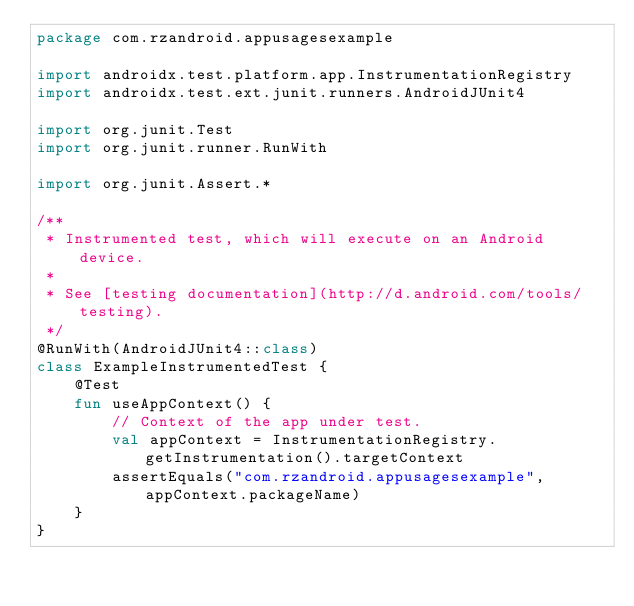<code> <loc_0><loc_0><loc_500><loc_500><_Kotlin_>package com.rzandroid.appusagesexample

import androidx.test.platform.app.InstrumentationRegistry
import androidx.test.ext.junit.runners.AndroidJUnit4

import org.junit.Test
import org.junit.runner.RunWith

import org.junit.Assert.*

/**
 * Instrumented test, which will execute on an Android device.
 *
 * See [testing documentation](http://d.android.com/tools/testing).
 */
@RunWith(AndroidJUnit4::class)
class ExampleInstrumentedTest {
    @Test
    fun useAppContext() {
        // Context of the app under test.
        val appContext = InstrumentationRegistry.getInstrumentation().targetContext
        assertEquals("com.rzandroid.appusagesexample", appContext.packageName)
    }
}</code> 